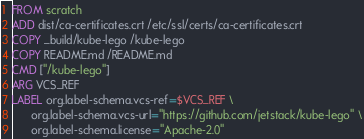<code> <loc_0><loc_0><loc_500><loc_500><_Dockerfile_>FROM scratch
ADD dist/ca-certificates.crt /etc/ssl/certs/ca-certificates.crt
COPY _build/kube-lego /kube-lego
COPY README.md /README.md
CMD ["/kube-lego"]
ARG VCS_REF
LABEL org.label-schema.vcs-ref=$VCS_REF \
      org.label-schema.vcs-url="https://github.com/jetstack/kube-lego" \
      org.label-schema.license="Apache-2.0"
</code> 